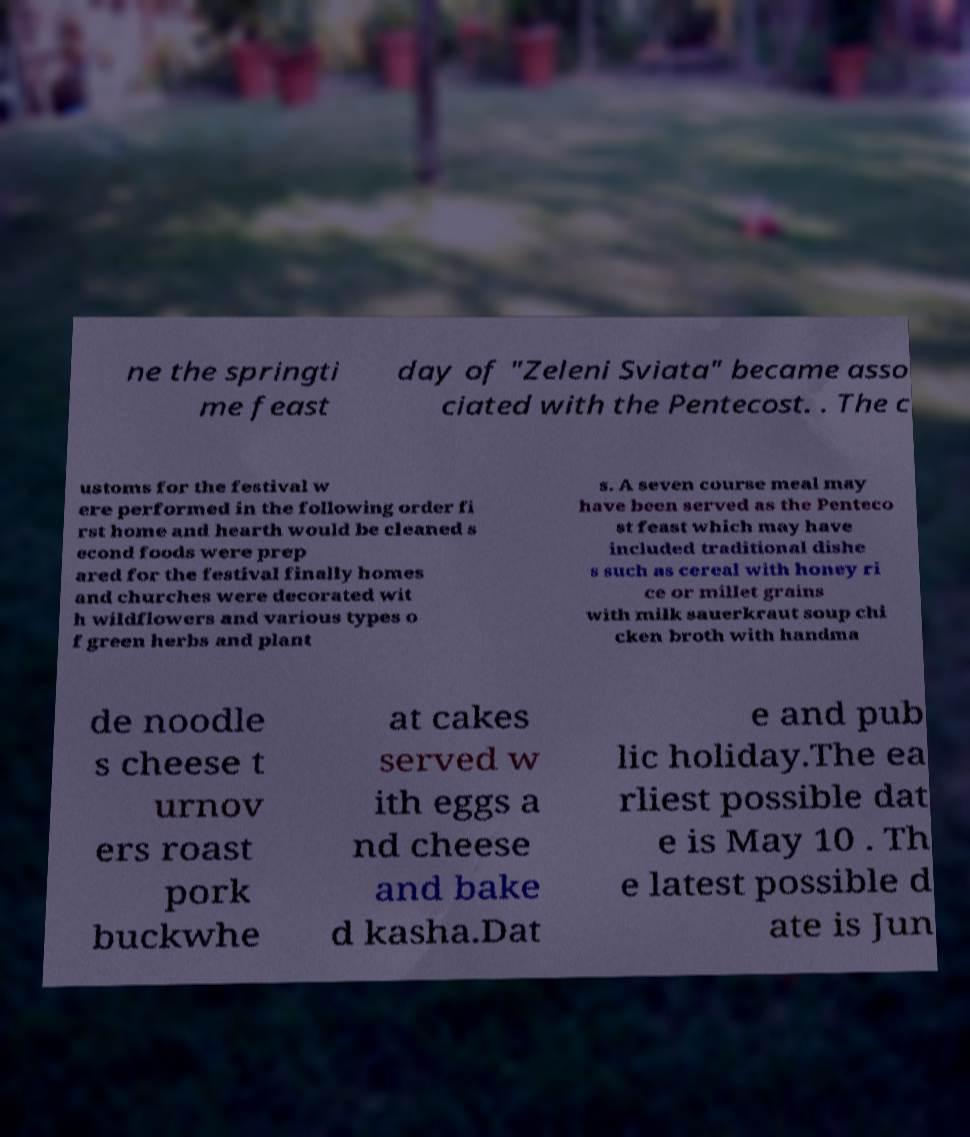Please read and relay the text visible in this image. What does it say? ne the springti me feast day of "Zeleni Sviata" became asso ciated with the Pentecost. . The c ustoms for the festival w ere performed in the following order fi rst home and hearth would be cleaned s econd foods were prep ared for the festival finally homes and churches were decorated wit h wildflowers and various types o f green herbs and plant s. A seven course meal may have been served as the Penteco st feast which may have included traditional dishe s such as cereal with honey ri ce or millet grains with milk sauerkraut soup chi cken broth with handma de noodle s cheese t urnov ers roast pork buckwhe at cakes served w ith eggs a nd cheese and bake d kasha.Dat e and pub lic holiday.The ea rliest possible dat e is May 10 . Th e latest possible d ate is Jun 